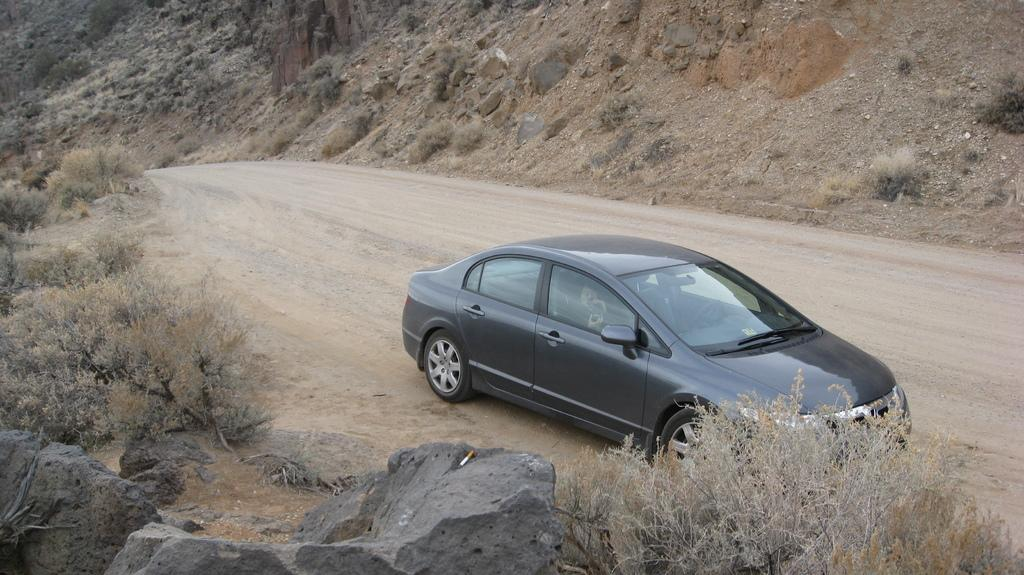What type of vehicle is in the image? There is a gray car in the image. Who or what is inside the car? There is a person sitting inside the car. What can be seen in the background of the image? There are trees visible in the background of the image. What type of ground surface is present in the image? There are stones present in the image. Can you tell me how many times the person inside the car requested a lift in the image? There is no indication in the image that the person requested a lift, so it cannot be determined from the picture. 